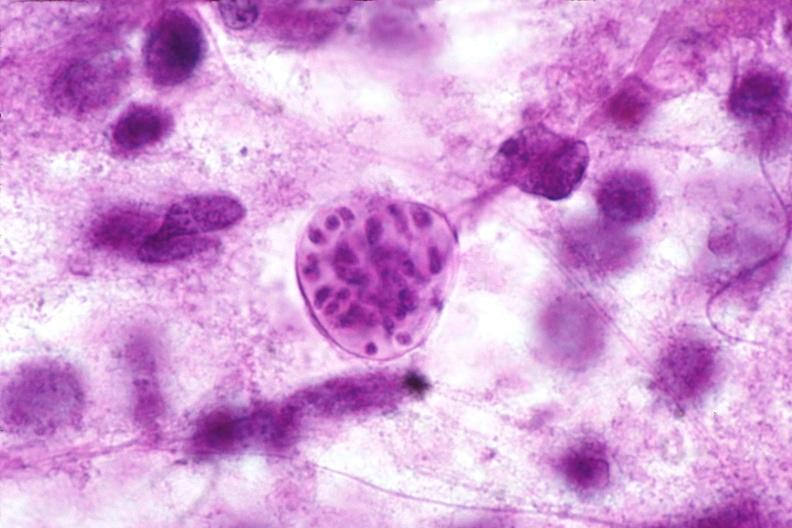s lesion present?
Answer the question using a single word or phrase. No 